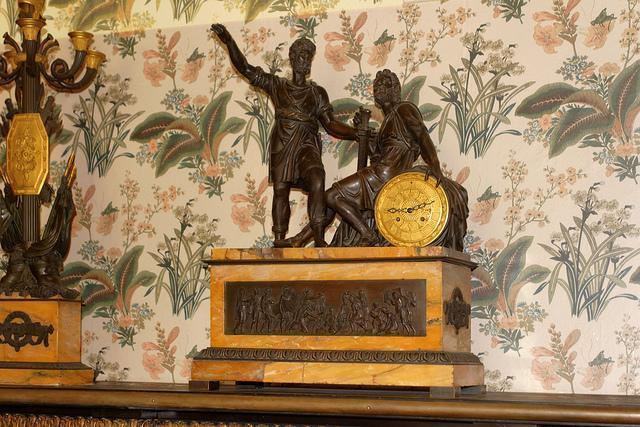How many statues are sitting on the clock?
Give a very brief answer. 2. 